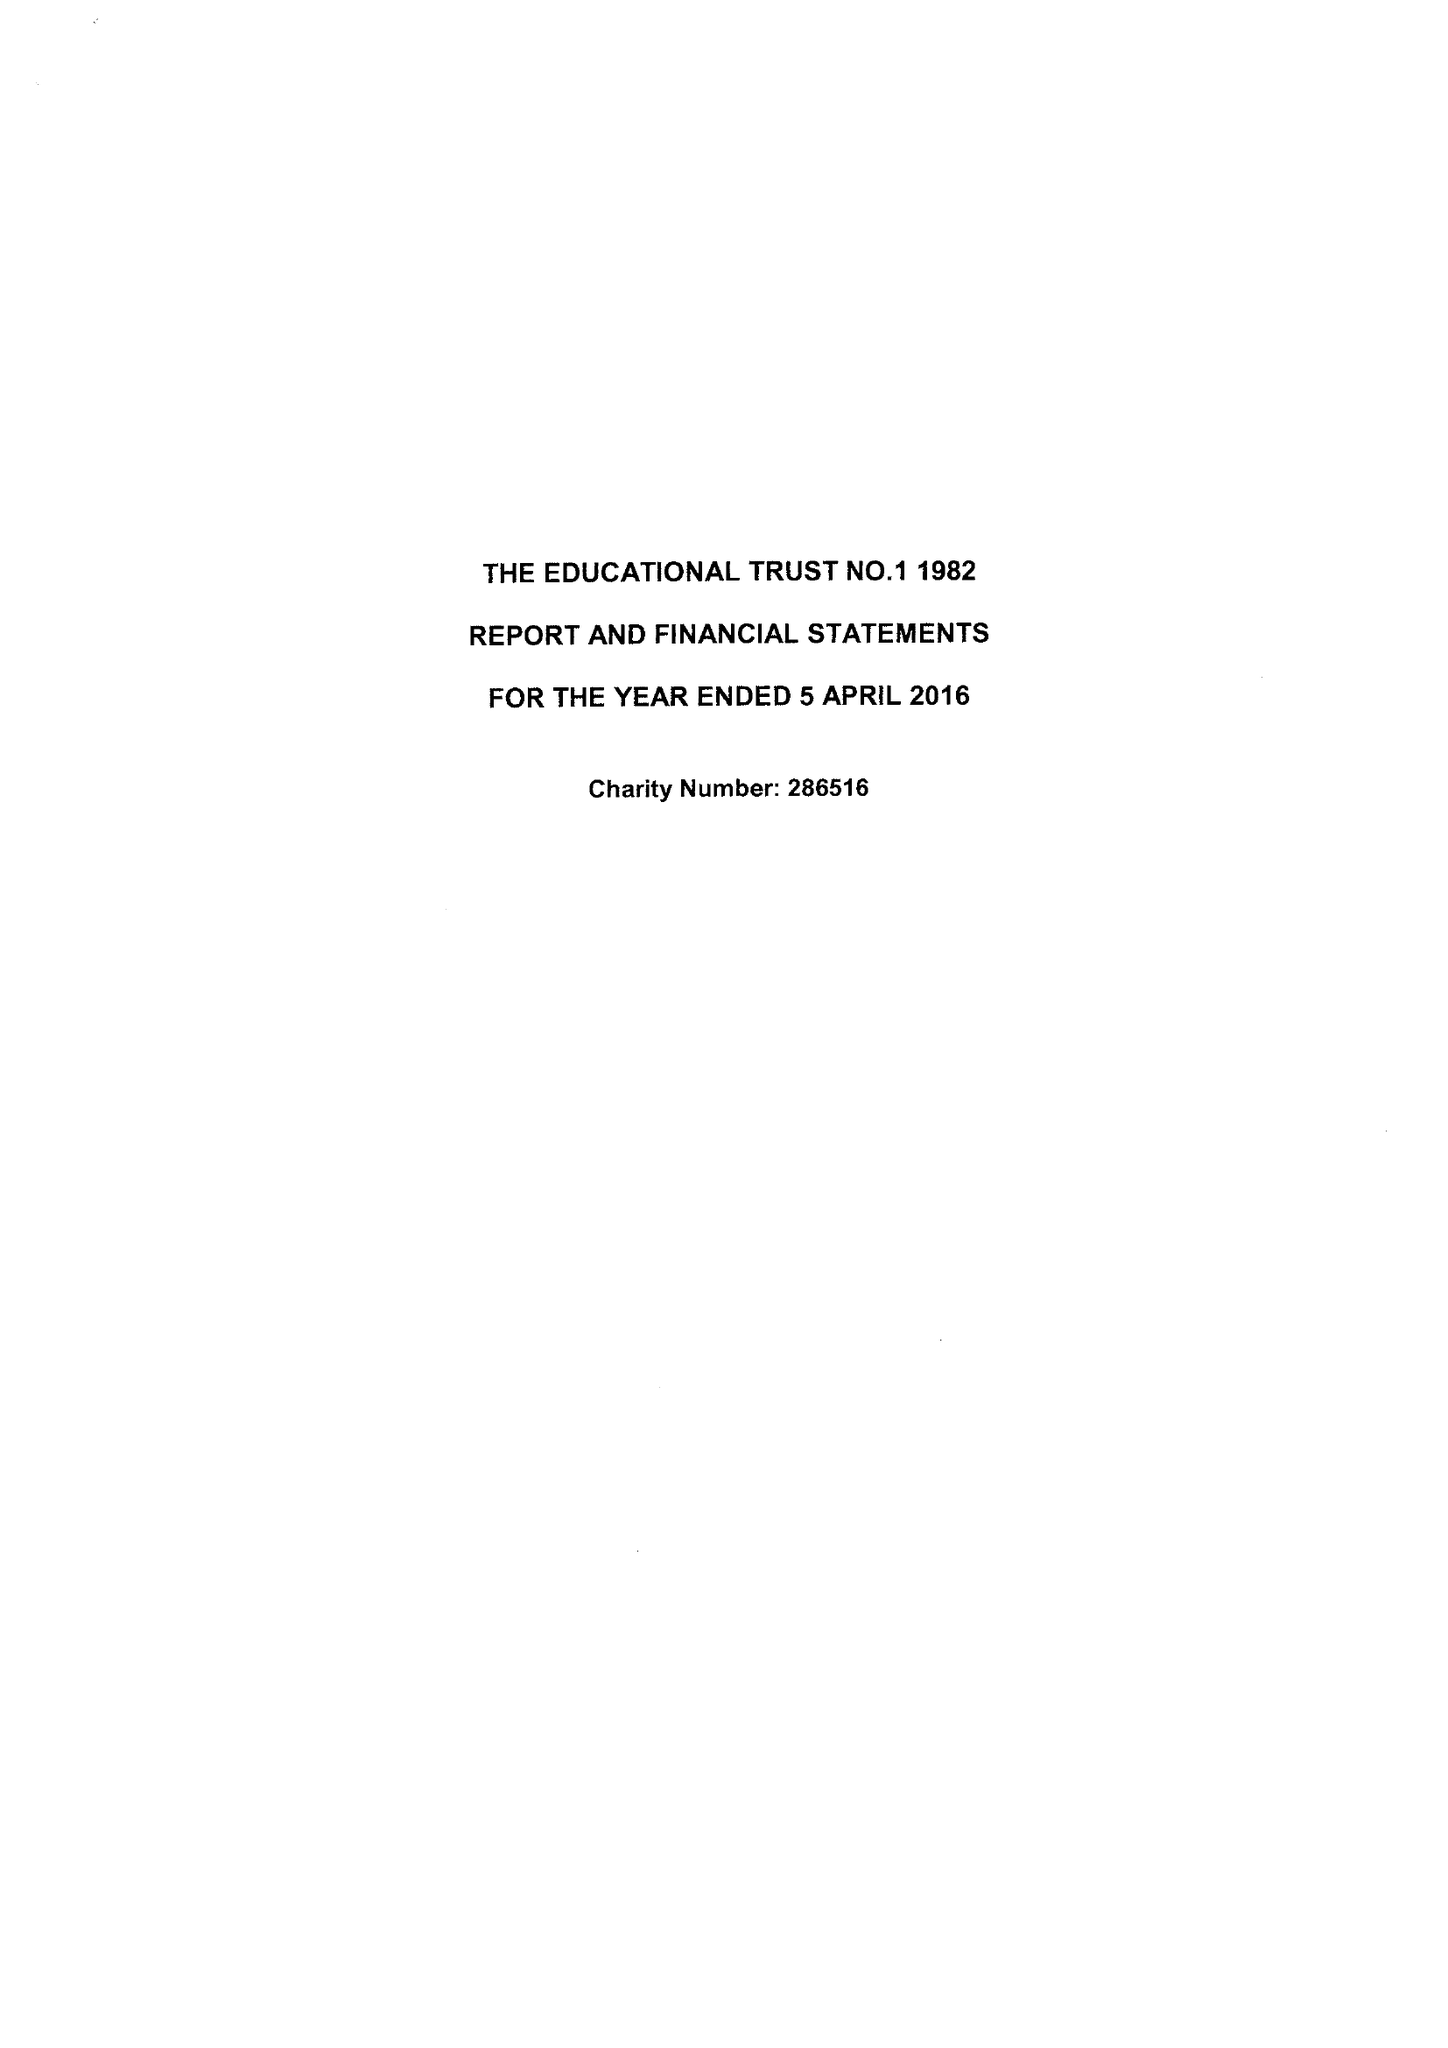What is the value for the charity_name?
Answer the question using a single word or phrase. Educational Trust No. 1 1982 